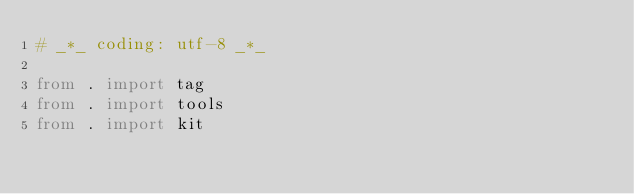Convert code to text. <code><loc_0><loc_0><loc_500><loc_500><_Python_># _*_ coding: utf-8 _*_

from . import tag
from . import tools
from . import kit
</code> 